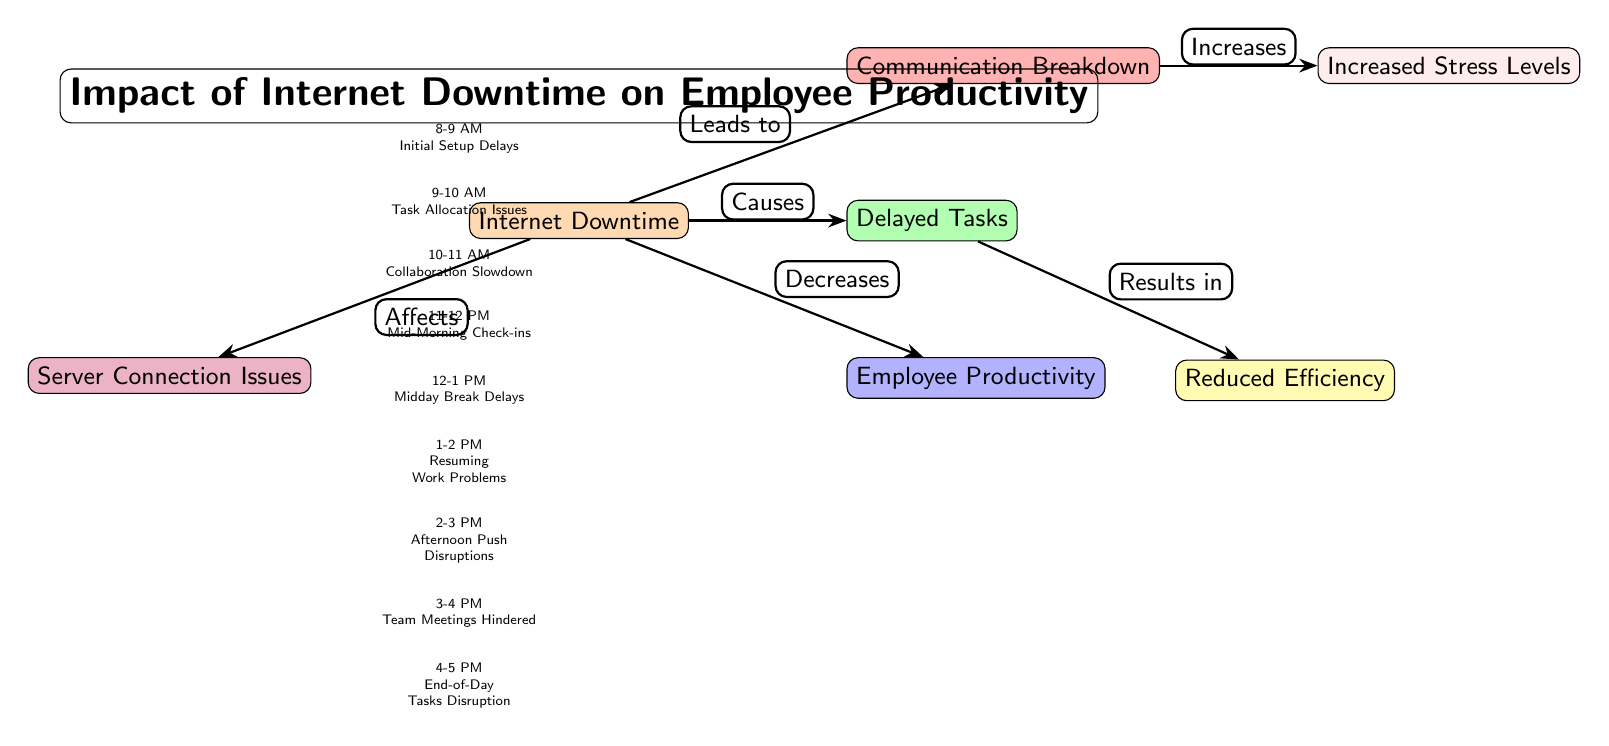What is the main focus of the diagram? The diagram is clearly labeled with the title "Impact of Internet Downtime on Employee Productivity." This provides the primary subject matter the diagram illustrates.
Answer: Impact of Internet Downtime on Employee Productivity How many main nodes are there in the diagram? Counting the colored nodes that represent key elements of the impact, there are six main nodes arranged around the central node of Internet Downtime.
Answer: Six What type of relationship connects Internet Downtime with Employee Productivity? The arrow between Internet Downtime and Employee Productivity is labeled "Decreases," indicating a negative impact of one on the other.
Answer: Decreases Which hourly breakdown has the most immediate concern? The first hourly breakdown listed, 8-9 AM, describes "Initial Setup Delays," which is the first instance of downtime affecting productivity, highlighting its immediate nature.
Answer: Initial Setup Delays What results from the connection between Delayed Tasks and Reduced Efficiency? The edge between Delayed Tasks and Reduced Efficiency is labeled "Results in," which indicates that delays in tasks directly lead to a decrease in efficiency.
Answer: Reduced Efficiency How does Internet Downtime affect Communication Breakdown? The edge labeled "Leads to" describes how Internet Downtime causes or contributes to a breakdown in communication, illustrating a directional relationship.
Answer: Leads to What impact does Communication Breakdown have on Increased Stress Levels? The connection is marked by "Increases," and suggests that when communication breaks down, the stress levels among employees rise as a direct consequence.
Answer: Increases What is the time period when Task Allocation Issues occur? Referring to the hourly breakdown listed below the central Internet Downtime node, Task Allocation Issues occur between 9-10 AM.
Answer: 9-10 AM Which hourly breakdown relates to End-of-Day Tasks Disruption? The last hourly impact described in the diagram is "End-of-Day Tasks Disruption," which occurs between 4-5 PM according to the hourly list.
Answer: 4-5 PM 